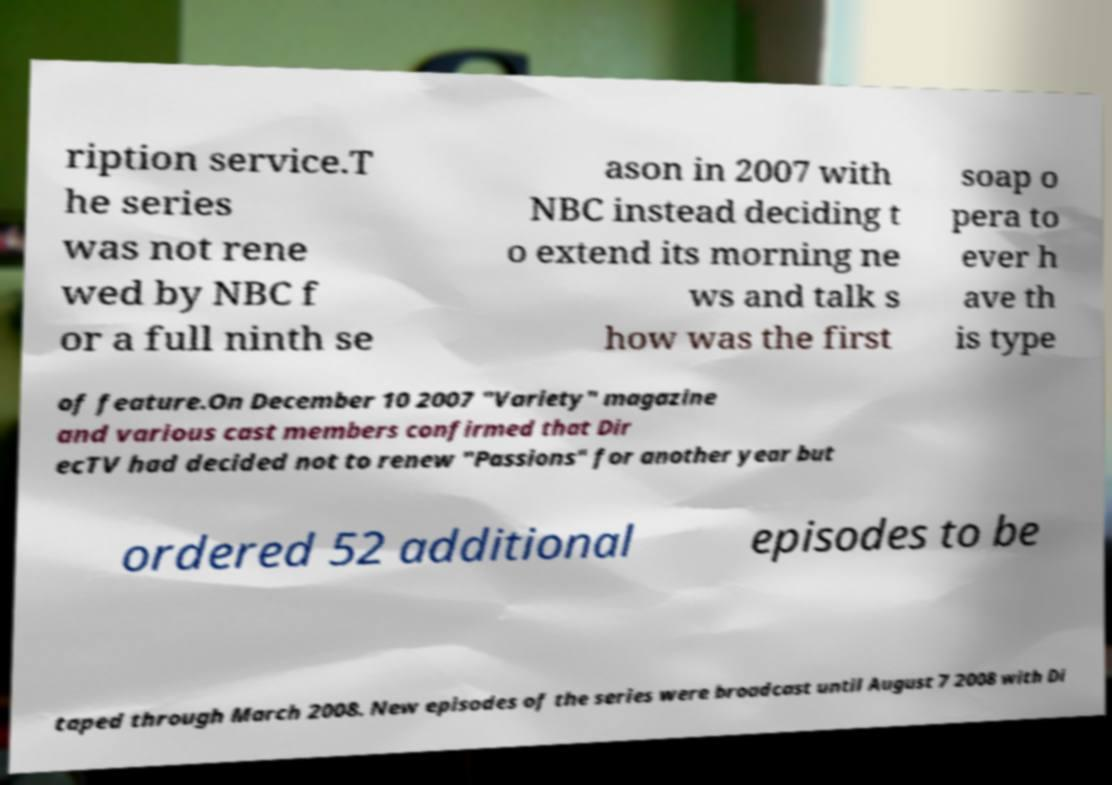I need the written content from this picture converted into text. Can you do that? ription service.T he series was not rene wed by NBC f or a full ninth se ason in 2007 with NBC instead deciding t o extend its morning ne ws and talk s how was the first soap o pera to ever h ave th is type of feature.On December 10 2007 "Variety" magazine and various cast members confirmed that Dir ecTV had decided not to renew "Passions" for another year but ordered 52 additional episodes to be taped through March 2008. New episodes of the series were broadcast until August 7 2008 with Di 